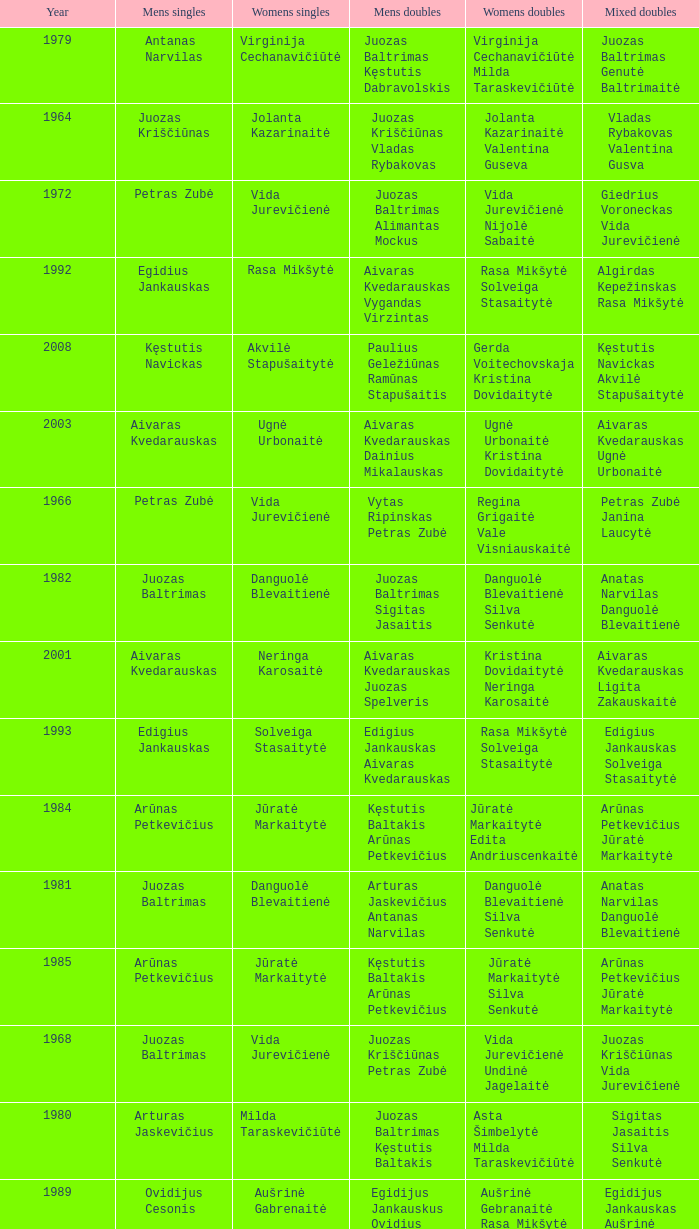What was the first year of the Lithuanian National Badminton Championships? 1963.0. 